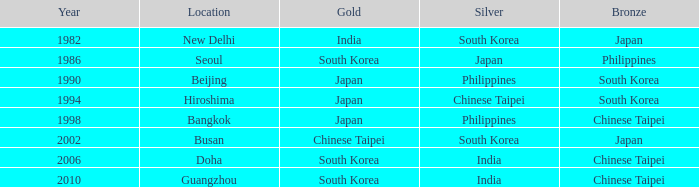How many years has Japan won silver? 1986.0. 